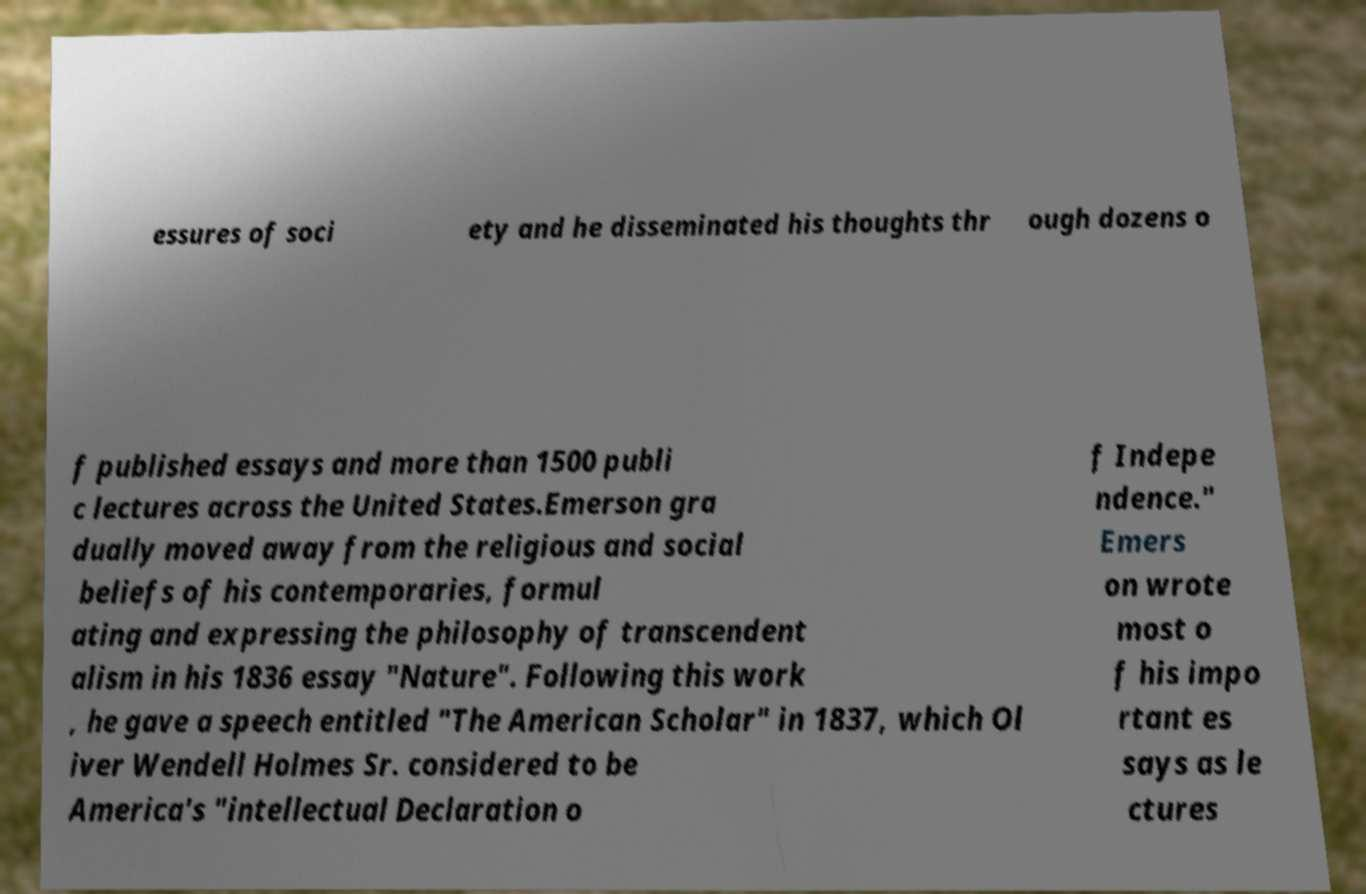What messages or text are displayed in this image? I need them in a readable, typed format. essures of soci ety and he disseminated his thoughts thr ough dozens o f published essays and more than 1500 publi c lectures across the United States.Emerson gra dually moved away from the religious and social beliefs of his contemporaries, formul ating and expressing the philosophy of transcendent alism in his 1836 essay "Nature". Following this work , he gave a speech entitled "The American Scholar" in 1837, which Ol iver Wendell Holmes Sr. considered to be America's "intellectual Declaration o f Indepe ndence." Emers on wrote most o f his impo rtant es says as le ctures 